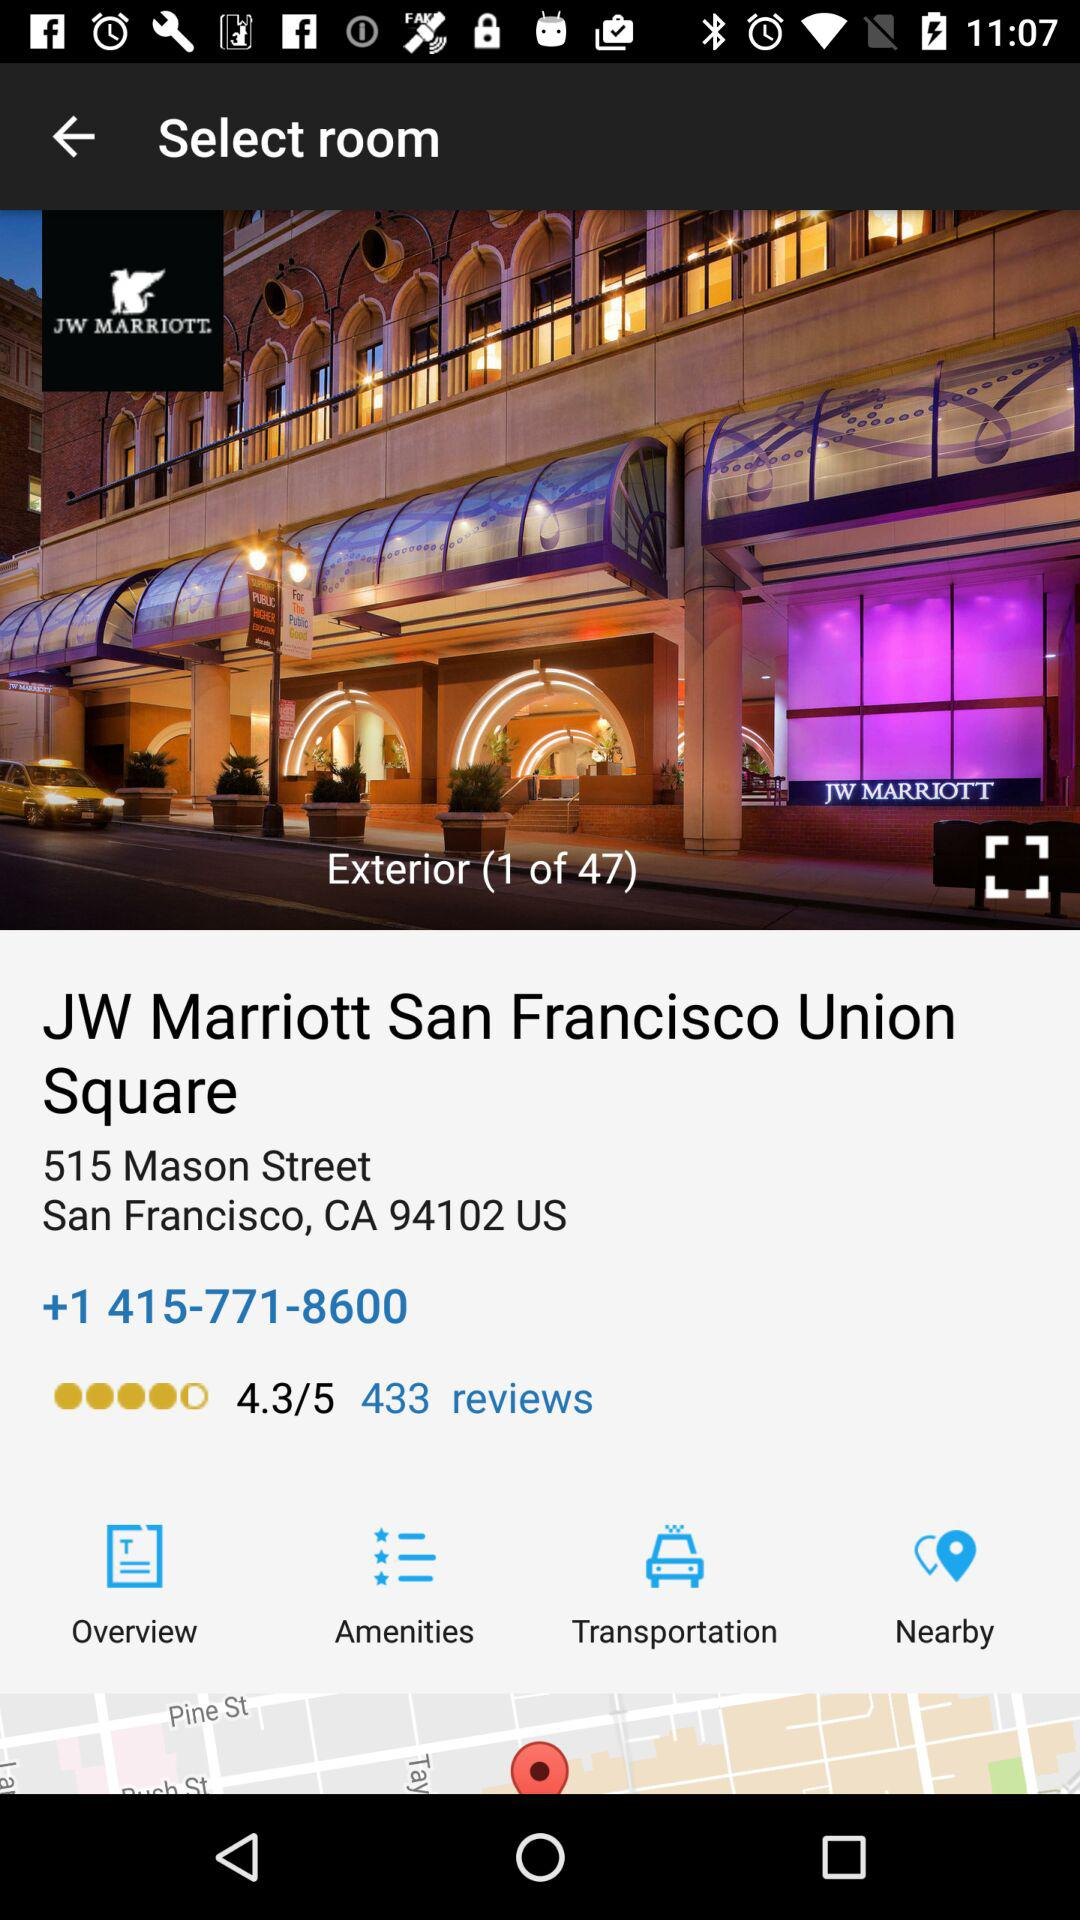What is the address of the JW Marriott? The address is "515 Mason Street San Francisco, CA 94102 US". 